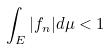Convert formula to latex. <formula><loc_0><loc_0><loc_500><loc_500>\int _ { E } | f _ { n } | d \mu < 1</formula> 